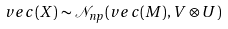<formula> <loc_0><loc_0><loc_500><loc_500>v e c ( X ) \sim { \mathcal { N } } _ { n p } ( v e c ( M ) , V \otimes U )</formula> 